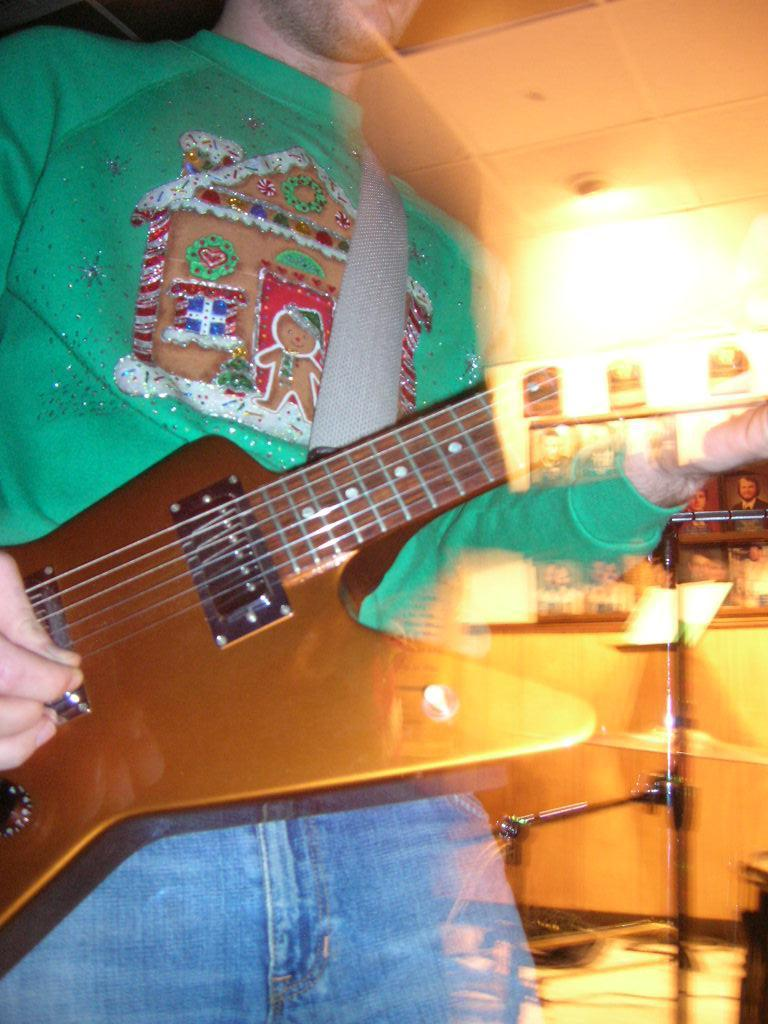What is the main subject of the image? There is a person in the image. What is the person doing in the image? The person is holding a musical instrument. What else can be seen in the image besides the person and the musical instrument? There are lights visible in the image. How many family members are present in the image? There is no information about family members in the image; it only shows a person holding a musical instrument and lights. What is the value of the glass in the image? There is no glass present in the image. 